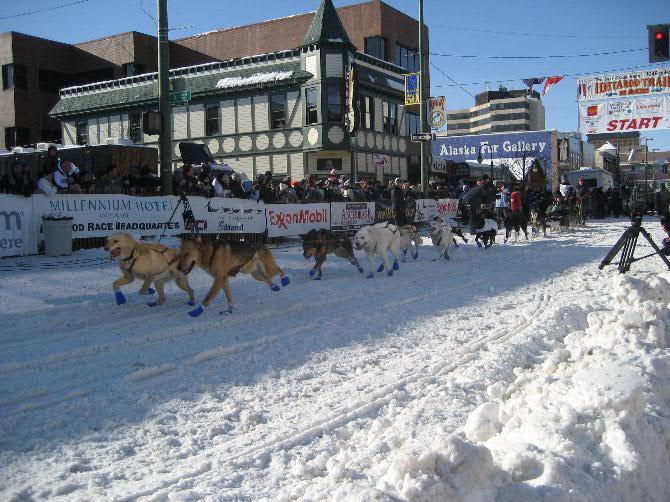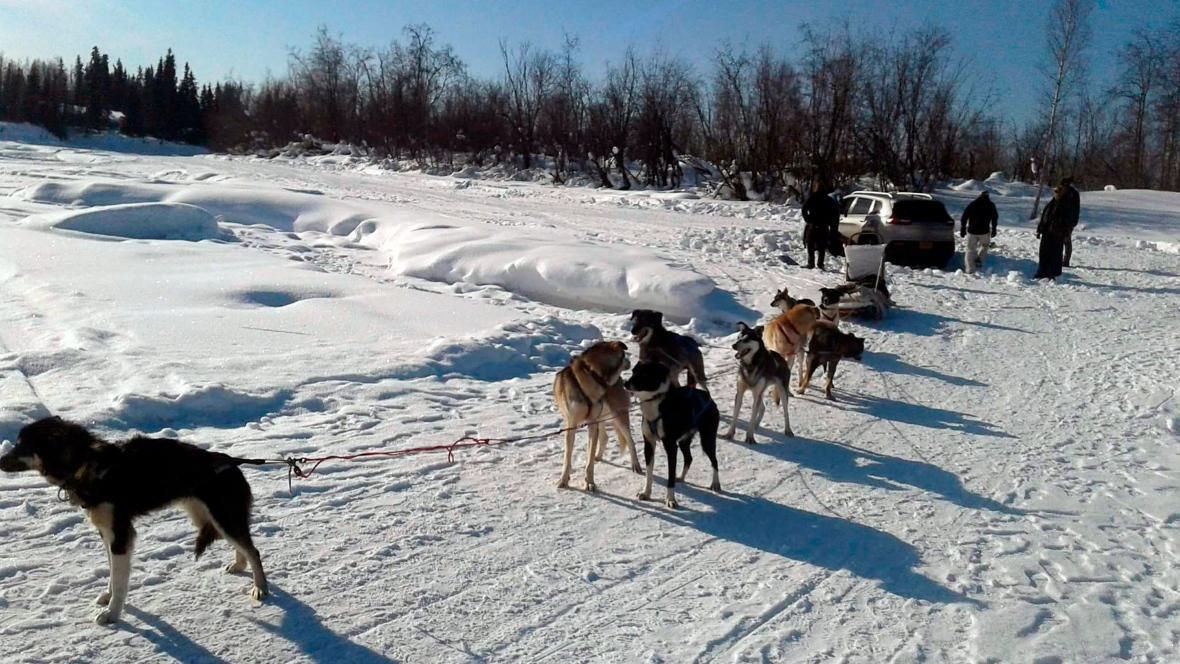The first image is the image on the left, the second image is the image on the right. For the images displayed, is the sentence "There is at least one person wearing a red coat in the image on the right." factually correct? Answer yes or no. No. 